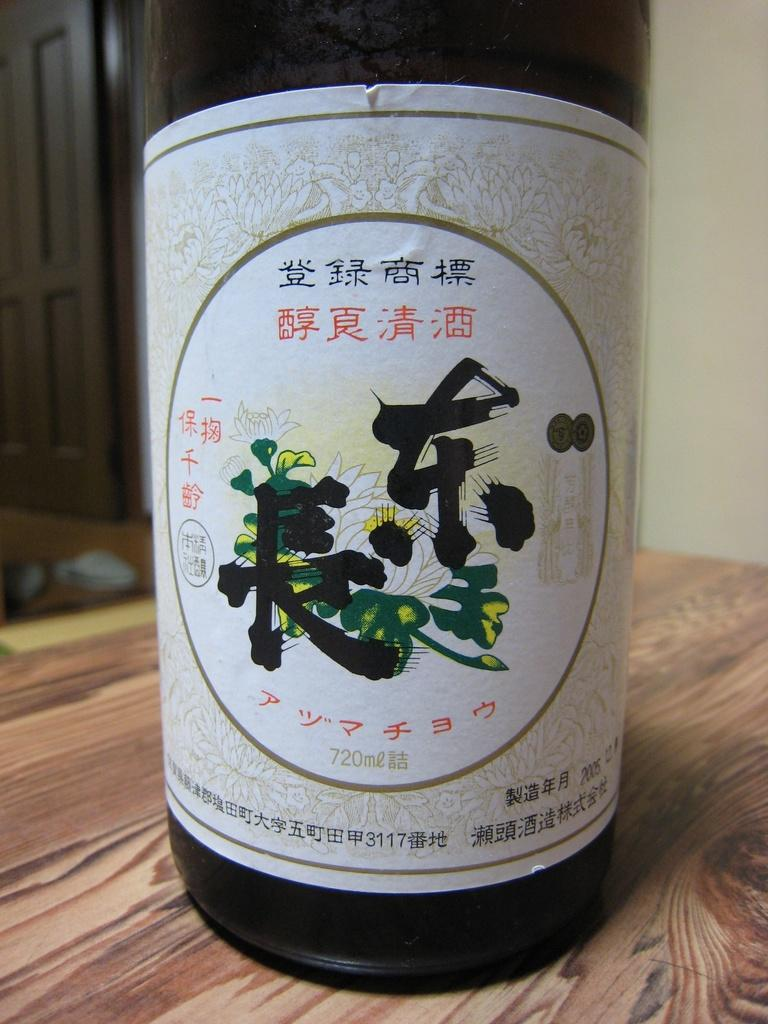What is located in the foreground of the image? There is a bottle in the foreground of the image. What is the bottle placed on? The bottle is on a wooden surface. Can you describe any architectural features in the image? Yes, there is a door in the image. What can be seen in the background of the image? There is an object in the background of the image. What type of pipe can be seen emitting sparks in the image? There is no pipe or sparks present in the image. What type of station is visible in the background of the image? There is no station visible in the background of the image. 